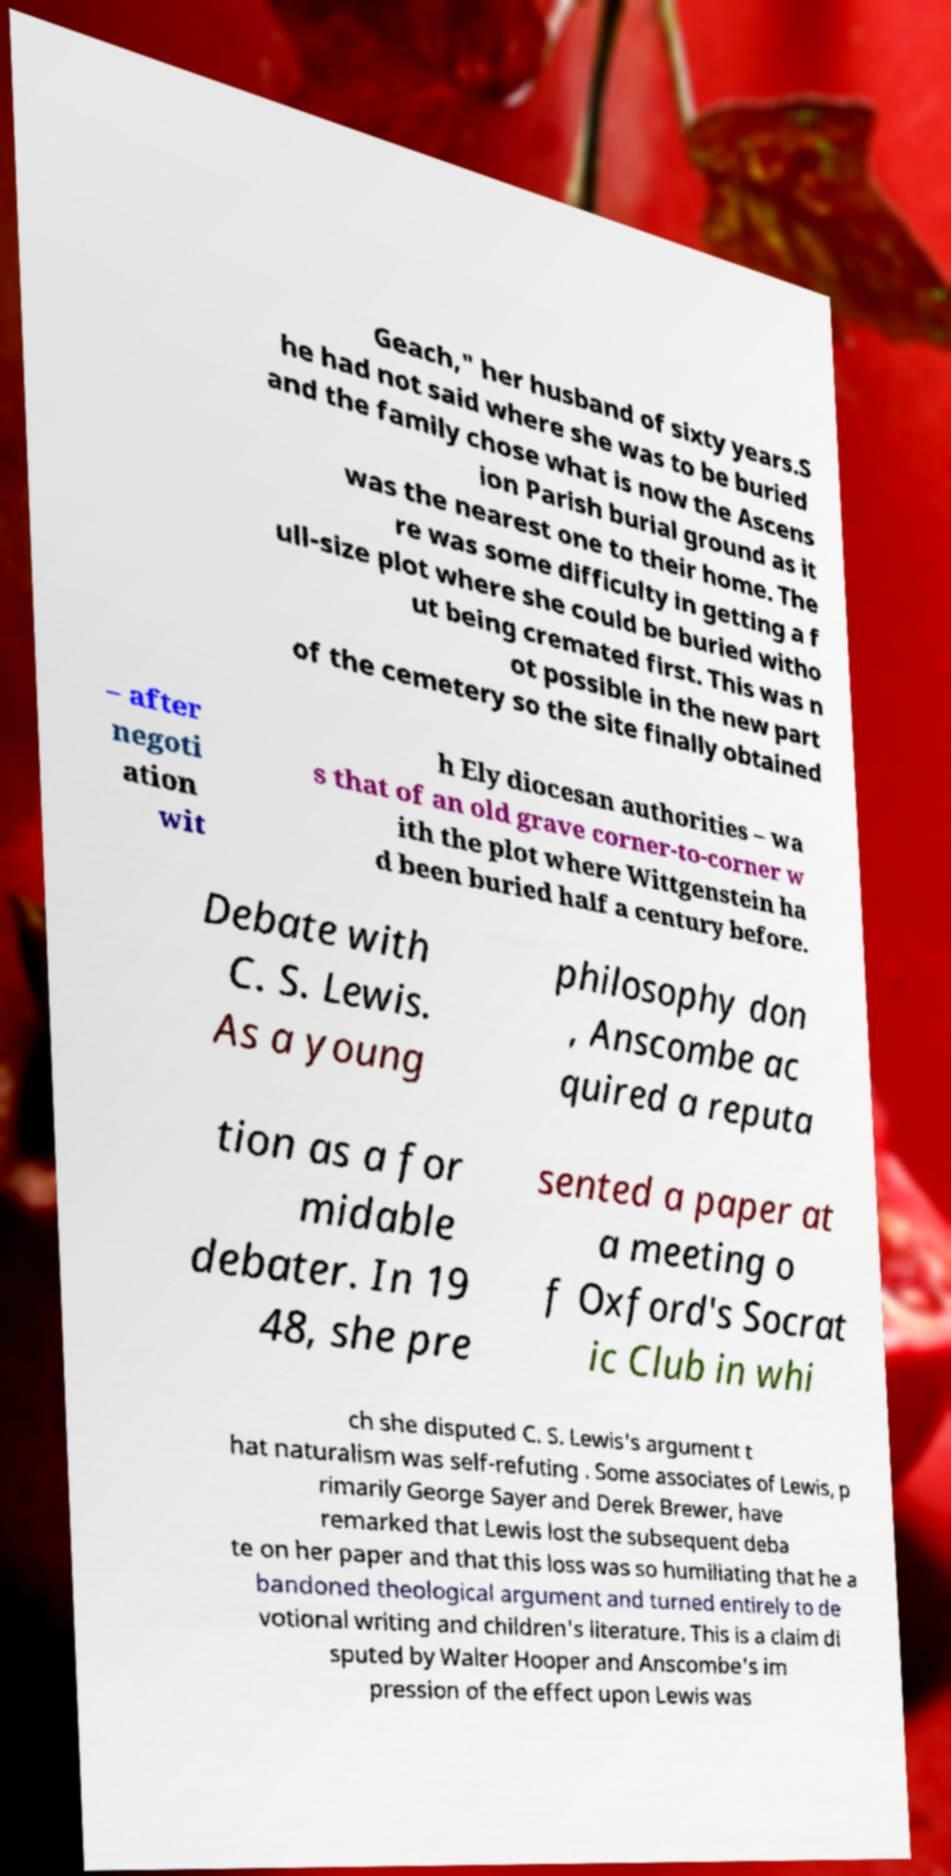For documentation purposes, I need the text within this image transcribed. Could you provide that? Geach," her husband of sixty years.S he had not said where she was to be buried and the family chose what is now the Ascens ion Parish burial ground as it was the nearest one to their home. The re was some difficulty in getting a f ull-size plot where she could be buried witho ut being cremated first. This was n ot possible in the new part of the cemetery so the site finally obtained – after negoti ation wit h Ely diocesan authorities – wa s that of an old grave corner-to-corner w ith the plot where Wittgenstein ha d been buried half a century before. Debate with C. S. Lewis. As a young philosophy don , Anscombe ac quired a reputa tion as a for midable debater. In 19 48, she pre sented a paper at a meeting o f Oxford's Socrat ic Club in whi ch she disputed C. S. Lewis's argument t hat naturalism was self-refuting . Some associates of Lewis, p rimarily George Sayer and Derek Brewer, have remarked that Lewis lost the subsequent deba te on her paper and that this loss was so humiliating that he a bandoned theological argument and turned entirely to de votional writing and children's literature. This is a claim di sputed by Walter Hooper and Anscombe's im pression of the effect upon Lewis was 